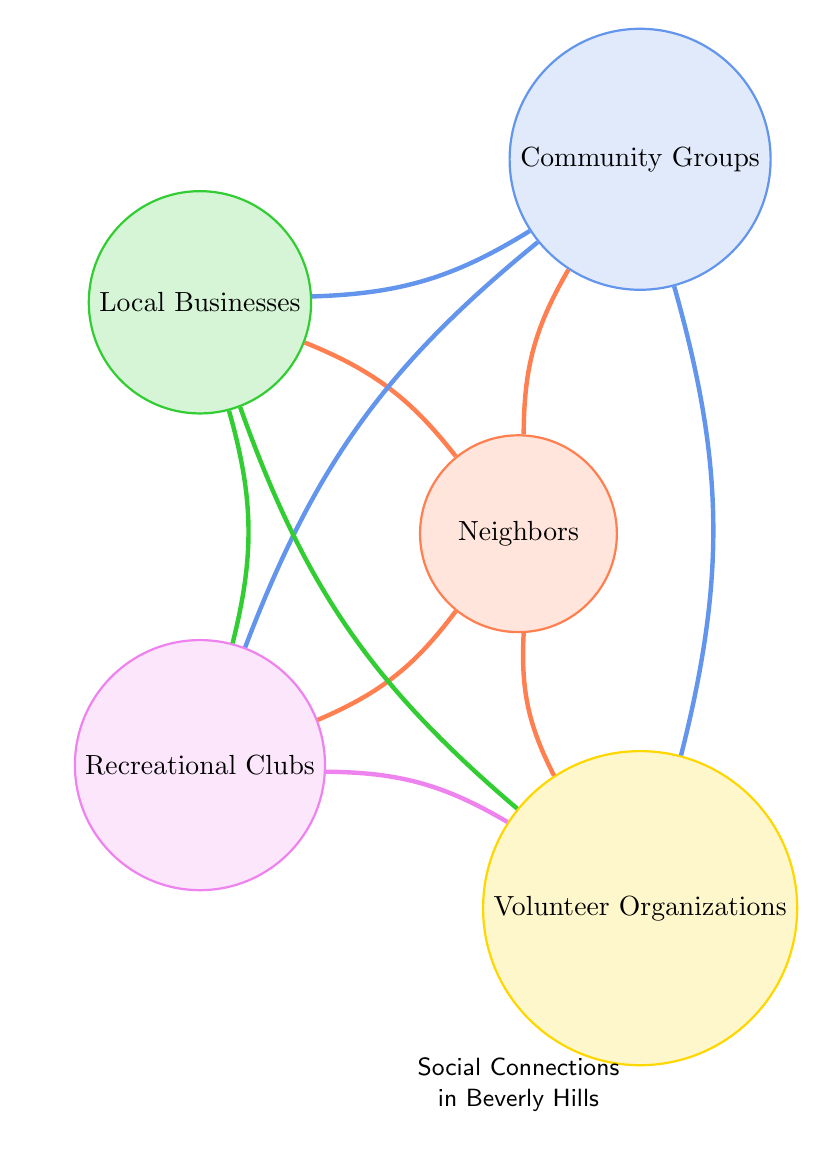What are the nodes in the diagram? The nodes in the diagram are represented as circles and are labeled with the following categories: Neighbors, Community Groups, Local Businesses, Recreational Clubs, and Volunteer Organizations.
Answer: Neighbors, Community Groups, Local Businesses, Recreational Clubs, Volunteer Organizations How many links are there in total? By counting the lines connecting the nodes, we can see that there are 10 distinct links, which represent the relationships between the categories.
Answer: 10 Which node has the most connections? The node "Neighbors" has more outgoing links to other nodes than any other node in the diagram, indicating it has multiple connections to Community Groups, Local Businesses, Recreational Clubs, and Volunteer Organizations.
Answer: Neighbors Is there a direct connection between Community Groups and Volunteer Organizations? By examining the links, we can see a line that connects Community Groups directly to Volunteer Organizations, indicating a direct relationship exists between them.
Answer: Yes How many nodes connect to Local Businesses? Looking at the links specifically connected to the node "Local Businesses", we see connections to Neighbors, Community Groups, Recreational Clubs, and Volunteer Organizations, totaling four connections.
Answer: 4 Which nodes are indirectly connected through Recreational Clubs? To find the nodes that are indirectly connected through Recreational Clubs, we start from Recreational Clubs and trace outwards to see that both Neighbors, Community Groups, and Volunteer Organizations link to Recreational Clubs. Hence, they are indirectly connected through it.
Answer: Neighbors, Community Groups, Volunteer Organizations What is the relationship pattern shown in this diagram? The diagram portrays a pattern of interconnectedness where Neighbors are central, connecting to various community elements, and other nodes are also related through multiple links, suggesting a strong community network.
Answer: Interconnectedness How many total connections does Recreational Clubs have? By inspecting the links to Recreational Clubs, we see it connects to Community Groups, Local Businesses, and Volunteer Organizations, indicating a total of three connections.
Answer: 3 Which two nodes share a common connection with Local Businesses? By observing the links from Local Businesses, we can note that both Recreational Clubs and Volunteer Organizations share connections with Local Businesses.
Answer: Recreational Clubs, Volunteer Organizations 